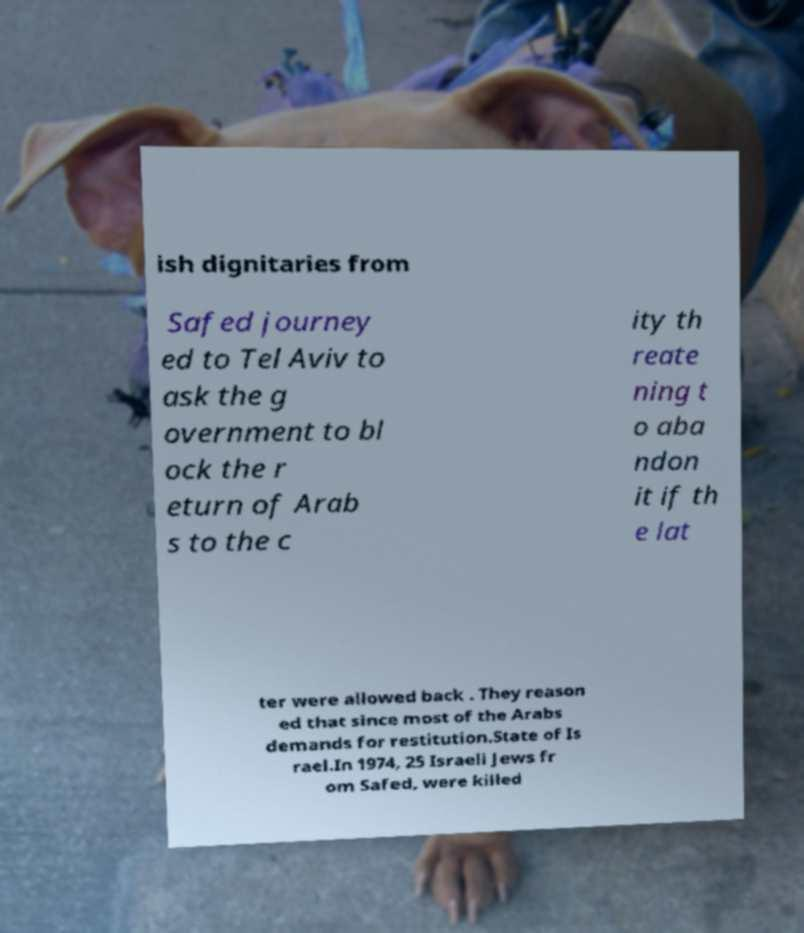There's text embedded in this image that I need extracted. Can you transcribe it verbatim? ish dignitaries from Safed journey ed to Tel Aviv to ask the g overnment to bl ock the r eturn of Arab s to the c ity th reate ning t o aba ndon it if th e lat ter were allowed back . They reason ed that since most of the Arabs demands for restitution.State of Is rael.In 1974, 25 Israeli Jews fr om Safed, were killed 